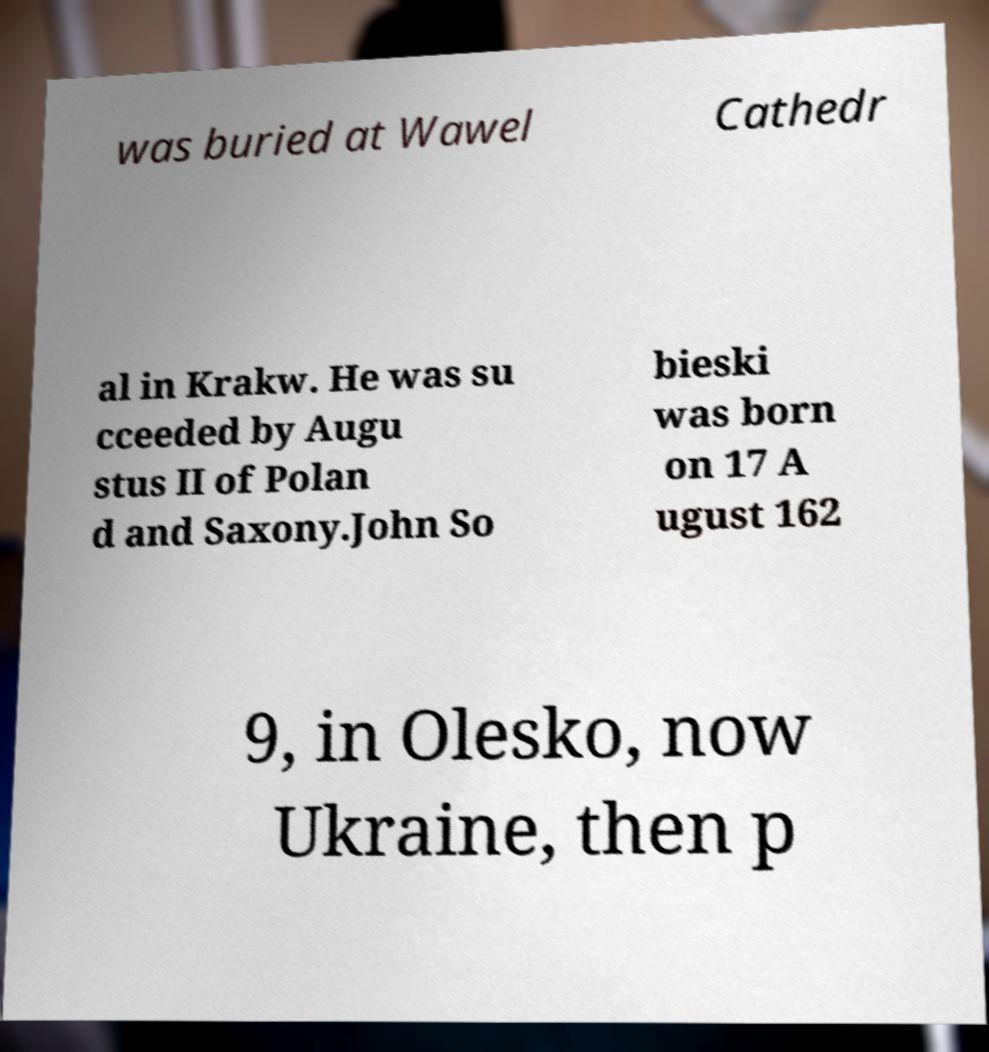Please read and relay the text visible in this image. What does it say? was buried at Wawel Cathedr al in Krakw. He was su cceeded by Augu stus II of Polan d and Saxony.John So bieski was born on 17 A ugust 162 9, in Olesko, now Ukraine, then p 